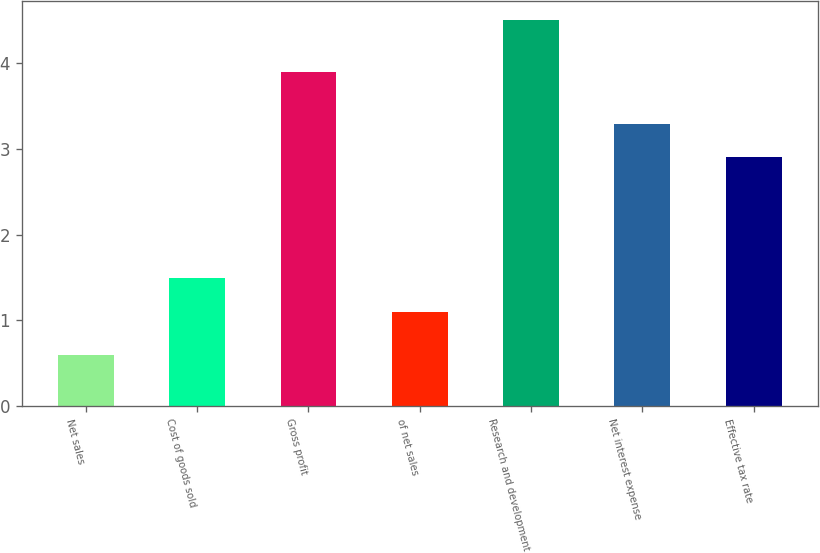Convert chart. <chart><loc_0><loc_0><loc_500><loc_500><bar_chart><fcel>Net sales<fcel>Cost of goods sold<fcel>Gross profit<fcel>of net sales<fcel>Research and development<fcel>Net interest expense<fcel>Effective tax rate<nl><fcel>0.6<fcel>1.49<fcel>3.9<fcel>1.1<fcel>4.5<fcel>3.29<fcel>2.9<nl></chart> 